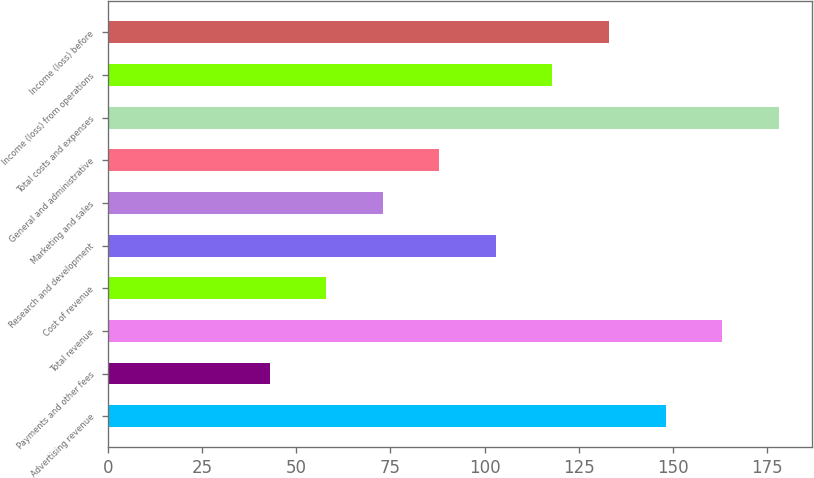Convert chart to OTSL. <chart><loc_0><loc_0><loc_500><loc_500><bar_chart><fcel>Advertising revenue<fcel>Payments and other fees<fcel>Total revenue<fcel>Cost of revenue<fcel>Research and development<fcel>Marketing and sales<fcel>General and administrative<fcel>Total costs and expenses<fcel>Income (loss) from operations<fcel>Income (loss) before<nl><fcel>148<fcel>43<fcel>163<fcel>58<fcel>103<fcel>73<fcel>88<fcel>178<fcel>118<fcel>133<nl></chart> 